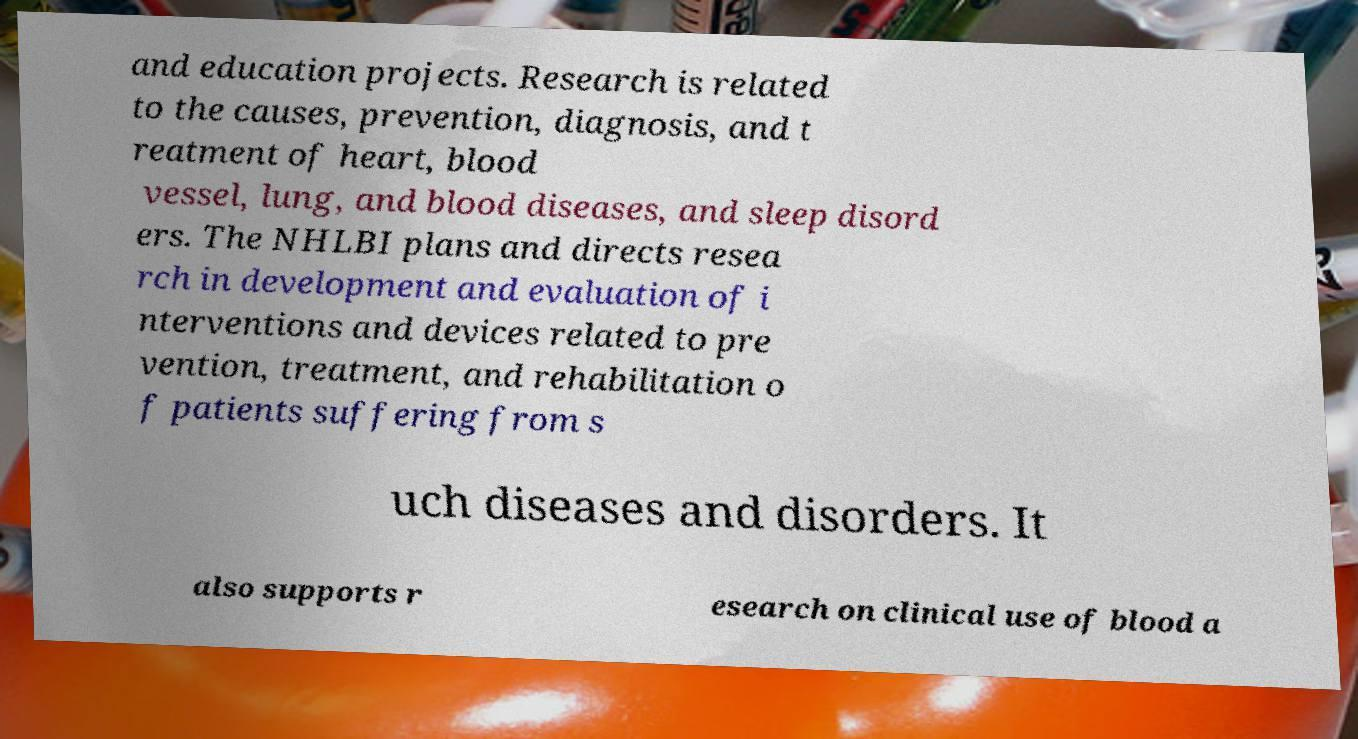Can you accurately transcribe the text from the provided image for me? and education projects. Research is related to the causes, prevention, diagnosis, and t reatment of heart, blood vessel, lung, and blood diseases, and sleep disord ers. The NHLBI plans and directs resea rch in development and evaluation of i nterventions and devices related to pre vention, treatment, and rehabilitation o f patients suffering from s uch diseases and disorders. It also supports r esearch on clinical use of blood a 